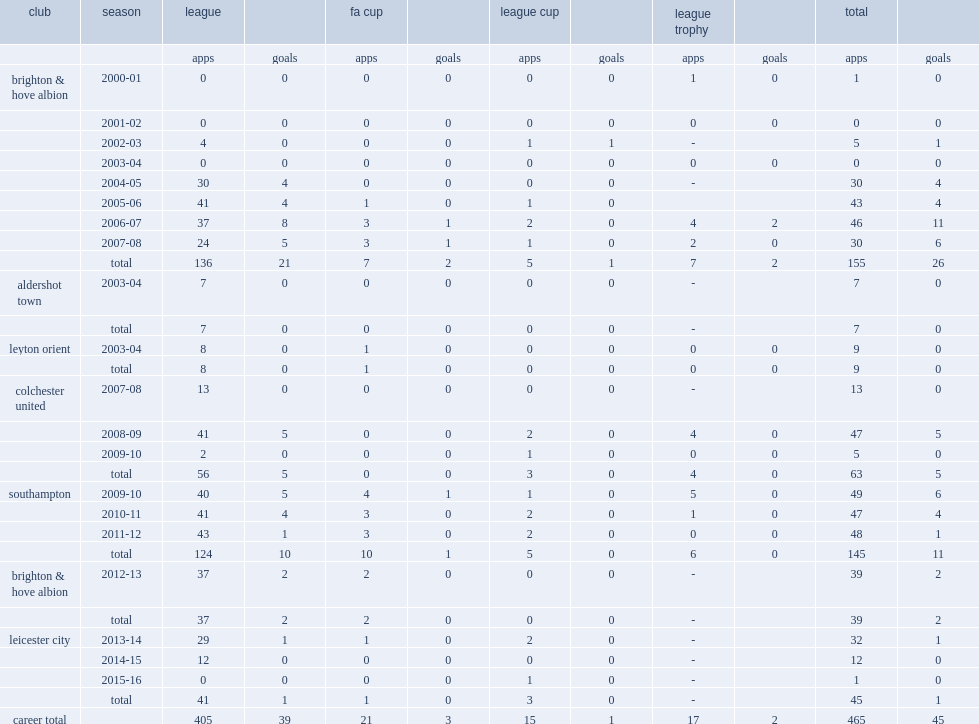How many goals did dean hammond score in league trophy? 2.0. 